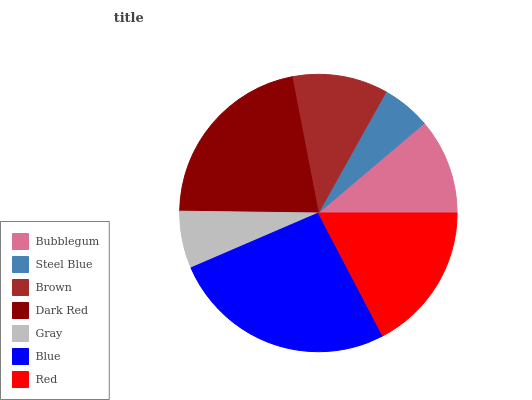Is Steel Blue the minimum?
Answer yes or no. Yes. Is Blue the maximum?
Answer yes or no. Yes. Is Brown the minimum?
Answer yes or no. No. Is Brown the maximum?
Answer yes or no. No. Is Brown greater than Steel Blue?
Answer yes or no. Yes. Is Steel Blue less than Brown?
Answer yes or no. Yes. Is Steel Blue greater than Brown?
Answer yes or no. No. Is Brown less than Steel Blue?
Answer yes or no. No. Is Bubblegum the high median?
Answer yes or no. Yes. Is Bubblegum the low median?
Answer yes or no. Yes. Is Red the high median?
Answer yes or no. No. Is Red the low median?
Answer yes or no. No. 